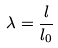<formula> <loc_0><loc_0><loc_500><loc_500>\lambda = \frac { l } { l _ { 0 } }</formula> 